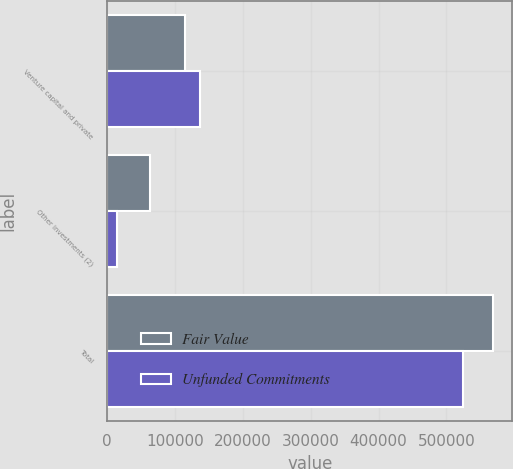<chart> <loc_0><loc_0><loc_500><loc_500><stacked_bar_chart><ecel><fcel>Venture capital and private<fcel>Other investments (2)<fcel>Total<nl><fcel>Fair Value<fcel>115337<fcel>62363<fcel>568947<nl><fcel>Unfunded Commitments<fcel>137168<fcel>13800<fcel>524107<nl></chart> 